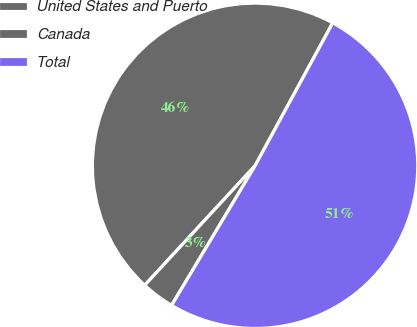Convert chart to OTSL. <chart><loc_0><loc_0><loc_500><loc_500><pie_chart><fcel>United States and Puerto<fcel>Canada<fcel>Total<nl><fcel>46.05%<fcel>3.29%<fcel>50.66%<nl></chart> 